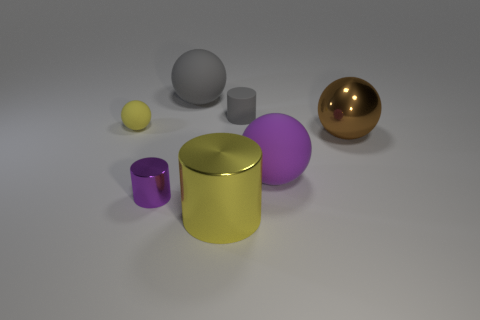Subtract all green spheres. Subtract all blue cubes. How many spheres are left? 4 Subtract all cyan blocks. How many red spheres are left? 0 Add 4 big objects. How many small purples exist? 0 Subtract all small brown rubber cylinders. Subtract all matte spheres. How many objects are left? 4 Add 6 large things. How many large things are left? 10 Add 4 large gray rubber cylinders. How many large gray rubber cylinders exist? 4 Add 1 large metallic objects. How many objects exist? 8 Subtract all gray spheres. How many spheres are left? 3 Subtract all big purple balls. How many balls are left? 3 Subtract 0 cyan blocks. How many objects are left? 7 